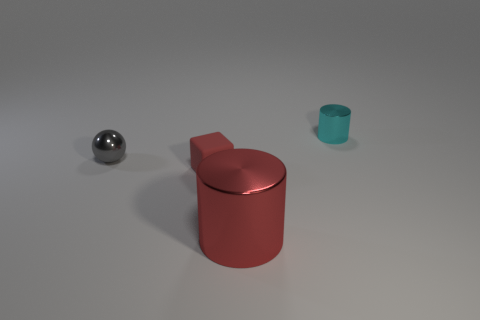What materials do the objects in the image seem to be made of? The ball has a reflective surface and could be made of a polished metal, whereas the cylinder and the cube appear to have a matte finish, possibly plastic or painted metal. 